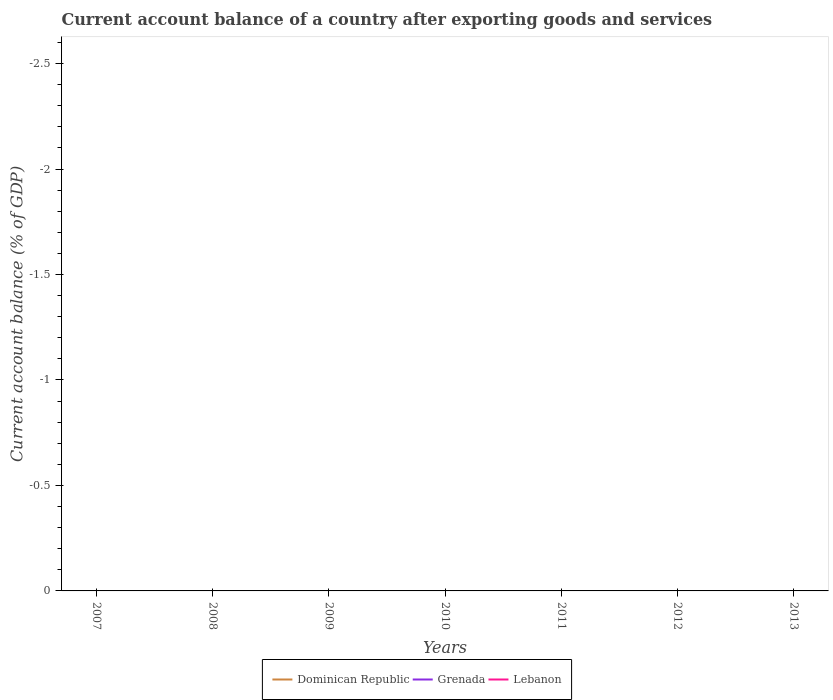Does the line corresponding to Grenada intersect with the line corresponding to Lebanon?
Your response must be concise. No. Is the number of lines equal to the number of legend labels?
Your answer should be very brief. No. Is the account balance in Lebanon strictly greater than the account balance in Grenada over the years?
Offer a very short reply. No. How many lines are there?
Provide a short and direct response. 0. What is the difference between two consecutive major ticks on the Y-axis?
Provide a short and direct response. 0.5. Does the graph contain any zero values?
Your response must be concise. Yes. Where does the legend appear in the graph?
Your answer should be compact. Bottom center. How are the legend labels stacked?
Ensure brevity in your answer.  Horizontal. What is the title of the graph?
Your response must be concise. Current account balance of a country after exporting goods and services. Does "Syrian Arab Republic" appear as one of the legend labels in the graph?
Ensure brevity in your answer.  No. What is the label or title of the X-axis?
Give a very brief answer. Years. What is the label or title of the Y-axis?
Offer a terse response. Current account balance (% of GDP). What is the Current account balance (% of GDP) of Dominican Republic in 2007?
Keep it short and to the point. 0. What is the Current account balance (% of GDP) of Grenada in 2007?
Ensure brevity in your answer.  0. What is the Current account balance (% of GDP) of Lebanon in 2007?
Your answer should be compact. 0. What is the Current account balance (% of GDP) of Dominican Republic in 2008?
Offer a very short reply. 0. What is the Current account balance (% of GDP) of Lebanon in 2008?
Keep it short and to the point. 0. What is the Current account balance (% of GDP) in Dominican Republic in 2010?
Offer a terse response. 0. What is the Current account balance (% of GDP) in Grenada in 2010?
Give a very brief answer. 0. What is the Current account balance (% of GDP) in Grenada in 2011?
Provide a short and direct response. 0. What is the Current account balance (% of GDP) of Lebanon in 2011?
Give a very brief answer. 0. What is the Current account balance (% of GDP) in Grenada in 2012?
Provide a succinct answer. 0. What is the Current account balance (% of GDP) of Grenada in 2013?
Provide a succinct answer. 0. What is the Current account balance (% of GDP) of Lebanon in 2013?
Make the answer very short. 0. What is the total Current account balance (% of GDP) of Lebanon in the graph?
Offer a very short reply. 0. What is the average Current account balance (% of GDP) of Dominican Republic per year?
Ensure brevity in your answer.  0. What is the average Current account balance (% of GDP) of Grenada per year?
Provide a succinct answer. 0. 